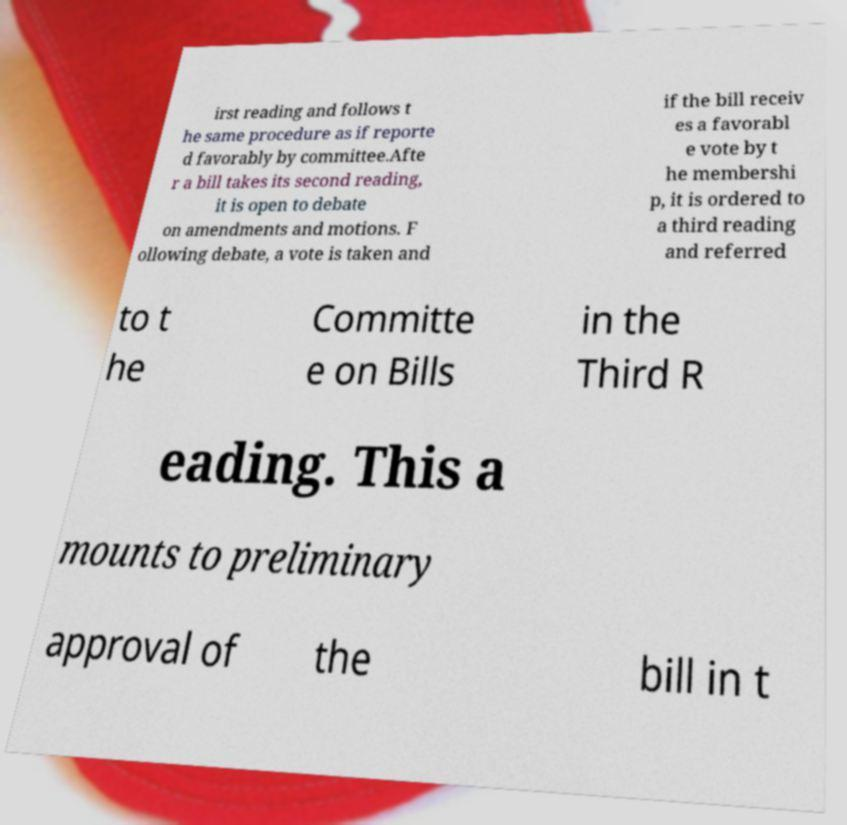Please read and relay the text visible in this image. What does it say? irst reading and follows t he same procedure as if reporte d favorably by committee.Afte r a bill takes its second reading, it is open to debate on amendments and motions. F ollowing debate, a vote is taken and if the bill receiv es a favorabl e vote by t he membershi p, it is ordered to a third reading and referred to t he Committe e on Bills in the Third R eading. This a mounts to preliminary approval of the bill in t 